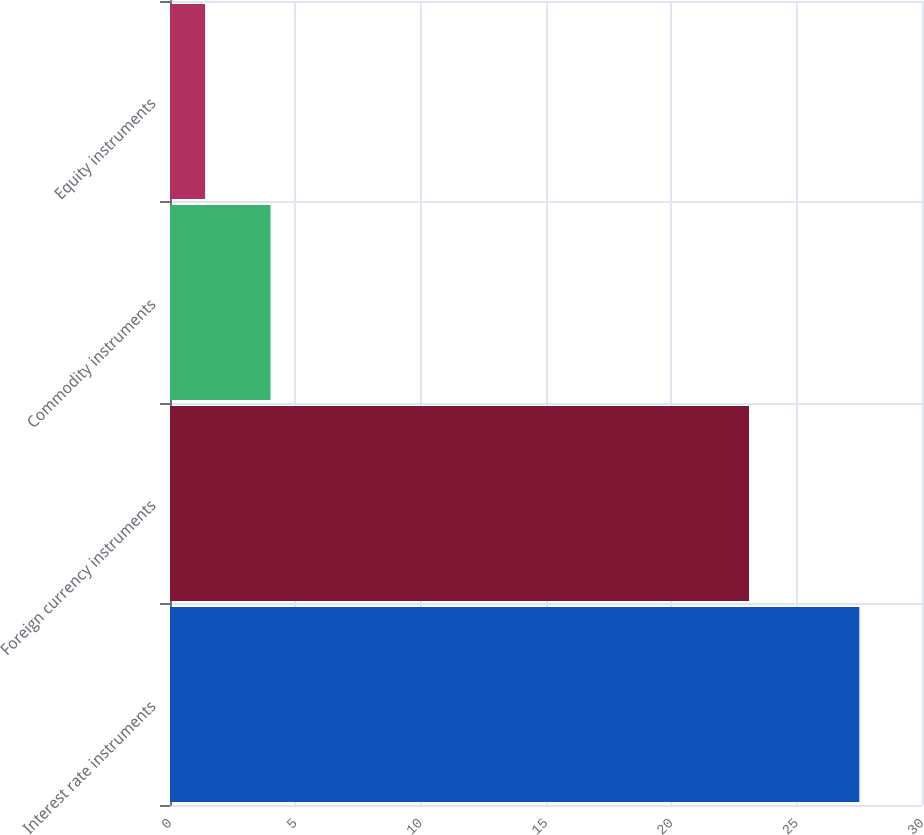Convert chart to OTSL. <chart><loc_0><loc_0><loc_500><loc_500><bar_chart><fcel>Interest rate instruments<fcel>Foreign currency instruments<fcel>Commodity instruments<fcel>Equity instruments<nl><fcel>27.5<fcel>23.1<fcel>4.01<fcel>1.4<nl></chart> 